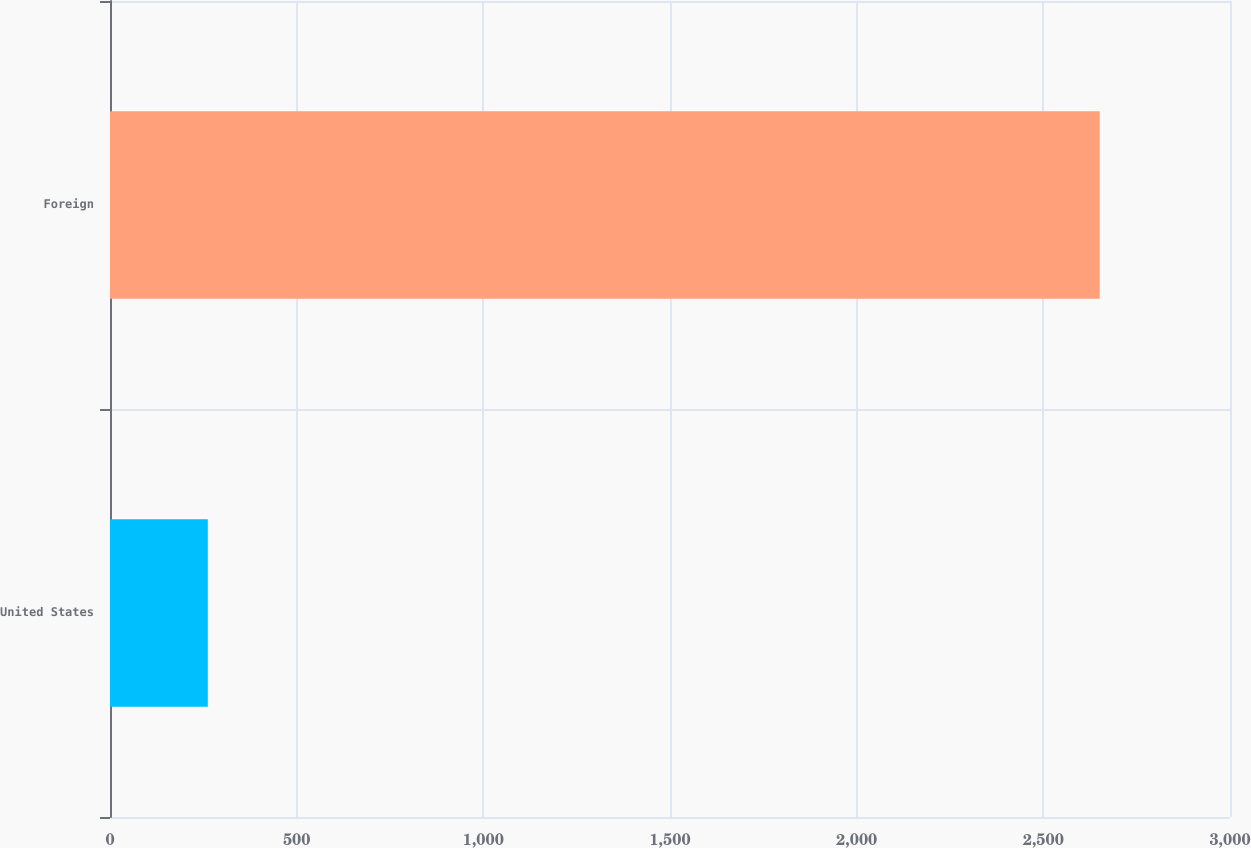<chart> <loc_0><loc_0><loc_500><loc_500><bar_chart><fcel>United States<fcel>Foreign<nl><fcel>262<fcel>2651<nl></chart> 